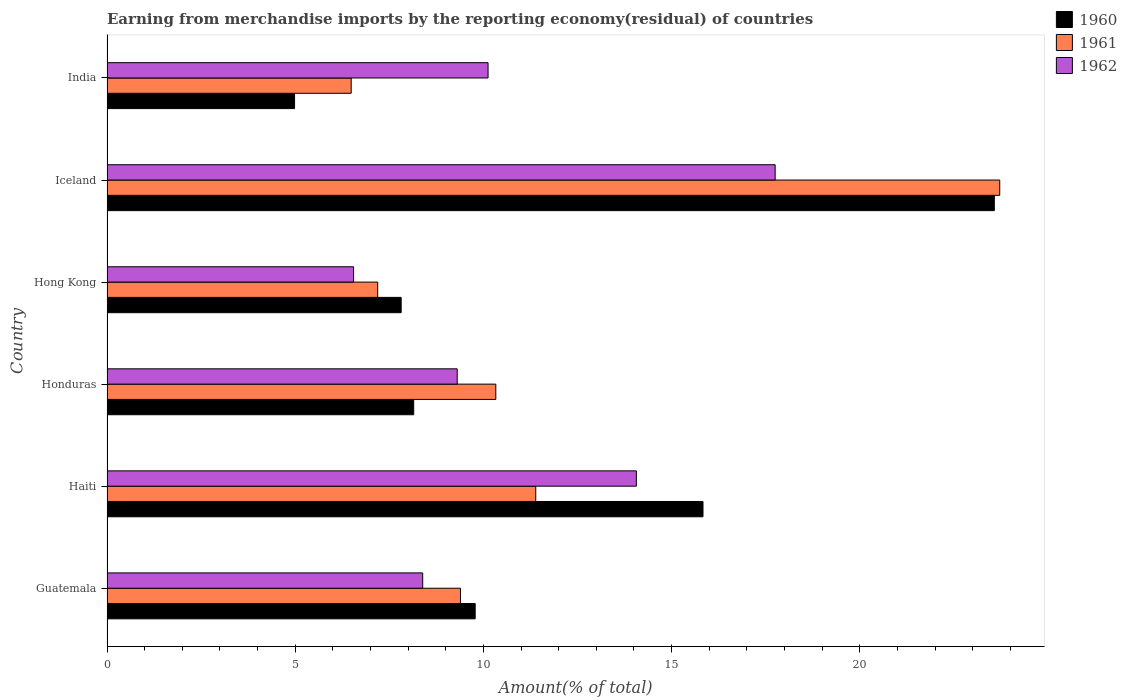How many different coloured bars are there?
Provide a short and direct response. 3. How many groups of bars are there?
Provide a succinct answer. 6. Are the number of bars on each tick of the Y-axis equal?
Your answer should be compact. Yes. In how many cases, is the number of bars for a given country not equal to the number of legend labels?
Your answer should be very brief. 0. What is the percentage of amount earned from merchandise imports in 1962 in Honduras?
Keep it short and to the point. 9.31. Across all countries, what is the maximum percentage of amount earned from merchandise imports in 1960?
Offer a terse response. 23.58. Across all countries, what is the minimum percentage of amount earned from merchandise imports in 1960?
Offer a terse response. 4.98. In which country was the percentage of amount earned from merchandise imports in 1960 minimum?
Your response must be concise. India. What is the total percentage of amount earned from merchandise imports in 1961 in the graph?
Your answer should be compact. 68.51. What is the difference between the percentage of amount earned from merchandise imports in 1962 in Guatemala and that in Iceland?
Give a very brief answer. -9.36. What is the difference between the percentage of amount earned from merchandise imports in 1961 in Guatemala and the percentage of amount earned from merchandise imports in 1962 in Hong Kong?
Make the answer very short. 2.84. What is the average percentage of amount earned from merchandise imports in 1962 per country?
Your answer should be very brief. 11.03. What is the difference between the percentage of amount earned from merchandise imports in 1960 and percentage of amount earned from merchandise imports in 1962 in Honduras?
Your answer should be very brief. -1.16. What is the ratio of the percentage of amount earned from merchandise imports in 1961 in Guatemala to that in Iceland?
Ensure brevity in your answer.  0.4. Is the difference between the percentage of amount earned from merchandise imports in 1960 in Guatemala and Hong Kong greater than the difference between the percentage of amount earned from merchandise imports in 1962 in Guatemala and Hong Kong?
Provide a succinct answer. Yes. What is the difference between the highest and the second highest percentage of amount earned from merchandise imports in 1962?
Give a very brief answer. 3.69. What is the difference between the highest and the lowest percentage of amount earned from merchandise imports in 1961?
Offer a very short reply. 17.23. Is the sum of the percentage of amount earned from merchandise imports in 1961 in Hong Kong and Iceland greater than the maximum percentage of amount earned from merchandise imports in 1960 across all countries?
Your answer should be very brief. Yes. Are the values on the major ticks of X-axis written in scientific E-notation?
Your answer should be compact. No. Does the graph contain grids?
Keep it short and to the point. No. Where does the legend appear in the graph?
Your answer should be very brief. Top right. How are the legend labels stacked?
Your answer should be compact. Vertical. What is the title of the graph?
Provide a succinct answer. Earning from merchandise imports by the reporting economy(residual) of countries. Does "1972" appear as one of the legend labels in the graph?
Keep it short and to the point. No. What is the label or title of the X-axis?
Offer a very short reply. Amount(% of total). What is the label or title of the Y-axis?
Provide a succinct answer. Country. What is the Amount(% of total) in 1960 in Guatemala?
Your response must be concise. 9.78. What is the Amount(% of total) in 1961 in Guatemala?
Your answer should be very brief. 9.39. What is the Amount(% of total) in 1962 in Guatemala?
Provide a succinct answer. 8.39. What is the Amount(% of total) of 1960 in Haiti?
Your response must be concise. 15.84. What is the Amount(% of total) in 1961 in Haiti?
Make the answer very short. 11.39. What is the Amount(% of total) in 1962 in Haiti?
Offer a very short reply. 14.06. What is the Amount(% of total) in 1960 in Honduras?
Make the answer very short. 8.15. What is the Amount(% of total) in 1961 in Honduras?
Keep it short and to the point. 10.33. What is the Amount(% of total) in 1962 in Honduras?
Ensure brevity in your answer.  9.31. What is the Amount(% of total) of 1960 in Hong Kong?
Your answer should be very brief. 7.82. What is the Amount(% of total) of 1961 in Hong Kong?
Your response must be concise. 7.19. What is the Amount(% of total) of 1962 in Hong Kong?
Your answer should be compact. 6.55. What is the Amount(% of total) in 1960 in Iceland?
Offer a terse response. 23.58. What is the Amount(% of total) in 1961 in Iceland?
Keep it short and to the point. 23.72. What is the Amount(% of total) of 1962 in Iceland?
Offer a very short reply. 17.75. What is the Amount(% of total) of 1960 in India?
Keep it short and to the point. 4.98. What is the Amount(% of total) in 1961 in India?
Offer a terse response. 6.49. What is the Amount(% of total) of 1962 in India?
Your answer should be very brief. 10.12. Across all countries, what is the maximum Amount(% of total) in 1960?
Your answer should be compact. 23.58. Across all countries, what is the maximum Amount(% of total) of 1961?
Your answer should be very brief. 23.72. Across all countries, what is the maximum Amount(% of total) of 1962?
Offer a very short reply. 17.75. Across all countries, what is the minimum Amount(% of total) in 1960?
Provide a succinct answer. 4.98. Across all countries, what is the minimum Amount(% of total) of 1961?
Offer a very short reply. 6.49. Across all countries, what is the minimum Amount(% of total) of 1962?
Provide a succinct answer. 6.55. What is the total Amount(% of total) in 1960 in the graph?
Make the answer very short. 70.14. What is the total Amount(% of total) of 1961 in the graph?
Keep it short and to the point. 68.51. What is the total Amount(% of total) of 1962 in the graph?
Give a very brief answer. 66.19. What is the difference between the Amount(% of total) in 1960 in Guatemala and that in Haiti?
Offer a very short reply. -6.05. What is the difference between the Amount(% of total) in 1961 in Guatemala and that in Haiti?
Ensure brevity in your answer.  -2. What is the difference between the Amount(% of total) of 1962 in Guatemala and that in Haiti?
Your answer should be compact. -5.68. What is the difference between the Amount(% of total) in 1960 in Guatemala and that in Honduras?
Provide a short and direct response. 1.63. What is the difference between the Amount(% of total) of 1961 in Guatemala and that in Honduras?
Offer a very short reply. -0.94. What is the difference between the Amount(% of total) of 1962 in Guatemala and that in Honduras?
Ensure brevity in your answer.  -0.92. What is the difference between the Amount(% of total) of 1960 in Guatemala and that in Hong Kong?
Make the answer very short. 1.97. What is the difference between the Amount(% of total) of 1961 in Guatemala and that in Hong Kong?
Give a very brief answer. 2.2. What is the difference between the Amount(% of total) of 1962 in Guatemala and that in Hong Kong?
Offer a very short reply. 1.84. What is the difference between the Amount(% of total) of 1960 in Guatemala and that in Iceland?
Provide a succinct answer. -13.79. What is the difference between the Amount(% of total) in 1961 in Guatemala and that in Iceland?
Provide a short and direct response. -14.33. What is the difference between the Amount(% of total) of 1962 in Guatemala and that in Iceland?
Your answer should be very brief. -9.36. What is the difference between the Amount(% of total) of 1960 in Guatemala and that in India?
Offer a very short reply. 4.8. What is the difference between the Amount(% of total) of 1961 in Guatemala and that in India?
Make the answer very short. 2.9. What is the difference between the Amount(% of total) of 1962 in Guatemala and that in India?
Provide a succinct answer. -1.74. What is the difference between the Amount(% of total) of 1960 in Haiti and that in Honduras?
Offer a very short reply. 7.69. What is the difference between the Amount(% of total) in 1961 in Haiti and that in Honduras?
Provide a succinct answer. 1.06. What is the difference between the Amount(% of total) of 1962 in Haiti and that in Honduras?
Offer a very short reply. 4.76. What is the difference between the Amount(% of total) of 1960 in Haiti and that in Hong Kong?
Offer a terse response. 8.02. What is the difference between the Amount(% of total) of 1961 in Haiti and that in Hong Kong?
Give a very brief answer. 4.2. What is the difference between the Amount(% of total) of 1962 in Haiti and that in Hong Kong?
Provide a succinct answer. 7.51. What is the difference between the Amount(% of total) of 1960 in Haiti and that in Iceland?
Offer a terse response. -7.74. What is the difference between the Amount(% of total) of 1961 in Haiti and that in Iceland?
Your response must be concise. -12.33. What is the difference between the Amount(% of total) in 1962 in Haiti and that in Iceland?
Offer a terse response. -3.69. What is the difference between the Amount(% of total) in 1960 in Haiti and that in India?
Provide a succinct answer. 10.85. What is the difference between the Amount(% of total) in 1961 in Haiti and that in India?
Your response must be concise. 4.9. What is the difference between the Amount(% of total) in 1962 in Haiti and that in India?
Provide a short and direct response. 3.94. What is the difference between the Amount(% of total) of 1961 in Honduras and that in Hong Kong?
Provide a succinct answer. 3.14. What is the difference between the Amount(% of total) of 1962 in Honduras and that in Hong Kong?
Your response must be concise. 2.75. What is the difference between the Amount(% of total) of 1960 in Honduras and that in Iceland?
Keep it short and to the point. -15.43. What is the difference between the Amount(% of total) of 1961 in Honduras and that in Iceland?
Provide a succinct answer. -13.39. What is the difference between the Amount(% of total) in 1962 in Honduras and that in Iceland?
Your response must be concise. -8.45. What is the difference between the Amount(% of total) in 1960 in Honduras and that in India?
Provide a short and direct response. 3.17. What is the difference between the Amount(% of total) in 1961 in Honduras and that in India?
Your response must be concise. 3.84. What is the difference between the Amount(% of total) of 1962 in Honduras and that in India?
Make the answer very short. -0.82. What is the difference between the Amount(% of total) of 1960 in Hong Kong and that in Iceland?
Provide a short and direct response. -15.76. What is the difference between the Amount(% of total) in 1961 in Hong Kong and that in Iceland?
Provide a succinct answer. -16.53. What is the difference between the Amount(% of total) of 1962 in Hong Kong and that in Iceland?
Ensure brevity in your answer.  -11.2. What is the difference between the Amount(% of total) of 1960 in Hong Kong and that in India?
Give a very brief answer. 2.83. What is the difference between the Amount(% of total) in 1961 in Hong Kong and that in India?
Give a very brief answer. 0.7. What is the difference between the Amount(% of total) of 1962 in Hong Kong and that in India?
Your answer should be very brief. -3.57. What is the difference between the Amount(% of total) of 1960 in Iceland and that in India?
Keep it short and to the point. 18.59. What is the difference between the Amount(% of total) in 1961 in Iceland and that in India?
Provide a succinct answer. 17.23. What is the difference between the Amount(% of total) in 1962 in Iceland and that in India?
Offer a terse response. 7.63. What is the difference between the Amount(% of total) in 1960 in Guatemala and the Amount(% of total) in 1961 in Haiti?
Offer a terse response. -1.61. What is the difference between the Amount(% of total) in 1960 in Guatemala and the Amount(% of total) in 1962 in Haiti?
Make the answer very short. -4.28. What is the difference between the Amount(% of total) of 1961 in Guatemala and the Amount(% of total) of 1962 in Haiti?
Provide a succinct answer. -4.67. What is the difference between the Amount(% of total) of 1960 in Guatemala and the Amount(% of total) of 1961 in Honduras?
Provide a succinct answer. -0.55. What is the difference between the Amount(% of total) in 1960 in Guatemala and the Amount(% of total) in 1962 in Honduras?
Your answer should be compact. 0.48. What is the difference between the Amount(% of total) of 1961 in Guatemala and the Amount(% of total) of 1962 in Honduras?
Your response must be concise. 0.09. What is the difference between the Amount(% of total) in 1960 in Guatemala and the Amount(% of total) in 1961 in Hong Kong?
Ensure brevity in your answer.  2.59. What is the difference between the Amount(% of total) in 1960 in Guatemala and the Amount(% of total) in 1962 in Hong Kong?
Make the answer very short. 3.23. What is the difference between the Amount(% of total) in 1961 in Guatemala and the Amount(% of total) in 1962 in Hong Kong?
Keep it short and to the point. 2.84. What is the difference between the Amount(% of total) of 1960 in Guatemala and the Amount(% of total) of 1961 in Iceland?
Provide a short and direct response. -13.94. What is the difference between the Amount(% of total) of 1960 in Guatemala and the Amount(% of total) of 1962 in Iceland?
Offer a terse response. -7.97. What is the difference between the Amount(% of total) in 1961 in Guatemala and the Amount(% of total) in 1962 in Iceland?
Keep it short and to the point. -8.36. What is the difference between the Amount(% of total) of 1960 in Guatemala and the Amount(% of total) of 1961 in India?
Your answer should be compact. 3.29. What is the difference between the Amount(% of total) in 1960 in Guatemala and the Amount(% of total) in 1962 in India?
Provide a short and direct response. -0.34. What is the difference between the Amount(% of total) in 1961 in Guatemala and the Amount(% of total) in 1962 in India?
Provide a succinct answer. -0.73. What is the difference between the Amount(% of total) in 1960 in Haiti and the Amount(% of total) in 1961 in Honduras?
Provide a short and direct response. 5.51. What is the difference between the Amount(% of total) in 1960 in Haiti and the Amount(% of total) in 1962 in Honduras?
Your response must be concise. 6.53. What is the difference between the Amount(% of total) in 1961 in Haiti and the Amount(% of total) in 1962 in Honduras?
Offer a very short reply. 2.09. What is the difference between the Amount(% of total) in 1960 in Haiti and the Amount(% of total) in 1961 in Hong Kong?
Keep it short and to the point. 8.64. What is the difference between the Amount(% of total) in 1960 in Haiti and the Amount(% of total) in 1962 in Hong Kong?
Ensure brevity in your answer.  9.28. What is the difference between the Amount(% of total) of 1961 in Haiti and the Amount(% of total) of 1962 in Hong Kong?
Provide a succinct answer. 4.84. What is the difference between the Amount(% of total) in 1960 in Haiti and the Amount(% of total) in 1961 in Iceland?
Your response must be concise. -7.88. What is the difference between the Amount(% of total) in 1960 in Haiti and the Amount(% of total) in 1962 in Iceland?
Make the answer very short. -1.92. What is the difference between the Amount(% of total) in 1961 in Haiti and the Amount(% of total) in 1962 in Iceland?
Your answer should be very brief. -6.36. What is the difference between the Amount(% of total) of 1960 in Haiti and the Amount(% of total) of 1961 in India?
Offer a very short reply. 9.35. What is the difference between the Amount(% of total) in 1960 in Haiti and the Amount(% of total) in 1962 in India?
Your response must be concise. 5.71. What is the difference between the Amount(% of total) of 1961 in Haiti and the Amount(% of total) of 1962 in India?
Offer a terse response. 1.27. What is the difference between the Amount(% of total) in 1960 in Honduras and the Amount(% of total) in 1961 in Hong Kong?
Ensure brevity in your answer.  0.96. What is the difference between the Amount(% of total) in 1960 in Honduras and the Amount(% of total) in 1962 in Hong Kong?
Your response must be concise. 1.6. What is the difference between the Amount(% of total) of 1961 in Honduras and the Amount(% of total) of 1962 in Hong Kong?
Provide a succinct answer. 3.78. What is the difference between the Amount(% of total) in 1960 in Honduras and the Amount(% of total) in 1961 in Iceland?
Ensure brevity in your answer.  -15.57. What is the difference between the Amount(% of total) in 1960 in Honduras and the Amount(% of total) in 1962 in Iceland?
Offer a very short reply. -9.6. What is the difference between the Amount(% of total) in 1961 in Honduras and the Amount(% of total) in 1962 in Iceland?
Offer a very short reply. -7.42. What is the difference between the Amount(% of total) in 1960 in Honduras and the Amount(% of total) in 1961 in India?
Keep it short and to the point. 1.66. What is the difference between the Amount(% of total) in 1960 in Honduras and the Amount(% of total) in 1962 in India?
Your answer should be very brief. -1.98. What is the difference between the Amount(% of total) of 1961 in Honduras and the Amount(% of total) of 1962 in India?
Give a very brief answer. 0.21. What is the difference between the Amount(% of total) in 1960 in Hong Kong and the Amount(% of total) in 1961 in Iceland?
Your response must be concise. -15.9. What is the difference between the Amount(% of total) in 1960 in Hong Kong and the Amount(% of total) in 1962 in Iceland?
Offer a very short reply. -9.94. What is the difference between the Amount(% of total) of 1961 in Hong Kong and the Amount(% of total) of 1962 in Iceland?
Your answer should be very brief. -10.56. What is the difference between the Amount(% of total) in 1960 in Hong Kong and the Amount(% of total) in 1961 in India?
Make the answer very short. 1.33. What is the difference between the Amount(% of total) of 1960 in Hong Kong and the Amount(% of total) of 1962 in India?
Provide a short and direct response. -2.31. What is the difference between the Amount(% of total) of 1961 in Hong Kong and the Amount(% of total) of 1962 in India?
Provide a short and direct response. -2.93. What is the difference between the Amount(% of total) of 1960 in Iceland and the Amount(% of total) of 1961 in India?
Offer a terse response. 17.09. What is the difference between the Amount(% of total) in 1960 in Iceland and the Amount(% of total) in 1962 in India?
Your answer should be compact. 13.45. What is the difference between the Amount(% of total) in 1961 in Iceland and the Amount(% of total) in 1962 in India?
Offer a terse response. 13.6. What is the average Amount(% of total) in 1960 per country?
Give a very brief answer. 11.69. What is the average Amount(% of total) of 1961 per country?
Your answer should be compact. 11.42. What is the average Amount(% of total) of 1962 per country?
Your answer should be very brief. 11.03. What is the difference between the Amount(% of total) of 1960 and Amount(% of total) of 1961 in Guatemala?
Give a very brief answer. 0.39. What is the difference between the Amount(% of total) in 1960 and Amount(% of total) in 1962 in Guatemala?
Provide a succinct answer. 1.39. What is the difference between the Amount(% of total) in 1961 and Amount(% of total) in 1962 in Guatemala?
Provide a short and direct response. 1. What is the difference between the Amount(% of total) of 1960 and Amount(% of total) of 1961 in Haiti?
Your answer should be very brief. 4.44. What is the difference between the Amount(% of total) in 1960 and Amount(% of total) in 1962 in Haiti?
Provide a succinct answer. 1.77. What is the difference between the Amount(% of total) of 1961 and Amount(% of total) of 1962 in Haiti?
Your response must be concise. -2.67. What is the difference between the Amount(% of total) of 1960 and Amount(% of total) of 1961 in Honduras?
Make the answer very short. -2.18. What is the difference between the Amount(% of total) in 1960 and Amount(% of total) in 1962 in Honduras?
Provide a succinct answer. -1.16. What is the difference between the Amount(% of total) in 1961 and Amount(% of total) in 1962 in Honduras?
Make the answer very short. 1.03. What is the difference between the Amount(% of total) in 1960 and Amount(% of total) in 1961 in Hong Kong?
Provide a succinct answer. 0.62. What is the difference between the Amount(% of total) of 1960 and Amount(% of total) of 1962 in Hong Kong?
Ensure brevity in your answer.  1.26. What is the difference between the Amount(% of total) in 1961 and Amount(% of total) in 1962 in Hong Kong?
Offer a very short reply. 0.64. What is the difference between the Amount(% of total) of 1960 and Amount(% of total) of 1961 in Iceland?
Keep it short and to the point. -0.14. What is the difference between the Amount(% of total) in 1960 and Amount(% of total) in 1962 in Iceland?
Ensure brevity in your answer.  5.82. What is the difference between the Amount(% of total) in 1961 and Amount(% of total) in 1962 in Iceland?
Provide a succinct answer. 5.97. What is the difference between the Amount(% of total) of 1960 and Amount(% of total) of 1961 in India?
Your answer should be compact. -1.5. What is the difference between the Amount(% of total) in 1960 and Amount(% of total) in 1962 in India?
Give a very brief answer. -5.14. What is the difference between the Amount(% of total) of 1961 and Amount(% of total) of 1962 in India?
Provide a succinct answer. -3.64. What is the ratio of the Amount(% of total) in 1960 in Guatemala to that in Haiti?
Provide a short and direct response. 0.62. What is the ratio of the Amount(% of total) of 1961 in Guatemala to that in Haiti?
Your answer should be very brief. 0.82. What is the ratio of the Amount(% of total) of 1962 in Guatemala to that in Haiti?
Offer a terse response. 0.6. What is the ratio of the Amount(% of total) of 1960 in Guatemala to that in Honduras?
Your answer should be compact. 1.2. What is the ratio of the Amount(% of total) in 1962 in Guatemala to that in Honduras?
Keep it short and to the point. 0.9. What is the ratio of the Amount(% of total) of 1960 in Guatemala to that in Hong Kong?
Your response must be concise. 1.25. What is the ratio of the Amount(% of total) in 1961 in Guatemala to that in Hong Kong?
Offer a terse response. 1.31. What is the ratio of the Amount(% of total) of 1962 in Guatemala to that in Hong Kong?
Provide a short and direct response. 1.28. What is the ratio of the Amount(% of total) of 1960 in Guatemala to that in Iceland?
Your answer should be compact. 0.41. What is the ratio of the Amount(% of total) of 1961 in Guatemala to that in Iceland?
Your answer should be very brief. 0.4. What is the ratio of the Amount(% of total) of 1962 in Guatemala to that in Iceland?
Keep it short and to the point. 0.47. What is the ratio of the Amount(% of total) in 1960 in Guatemala to that in India?
Your response must be concise. 1.96. What is the ratio of the Amount(% of total) of 1961 in Guatemala to that in India?
Your answer should be very brief. 1.45. What is the ratio of the Amount(% of total) of 1962 in Guatemala to that in India?
Keep it short and to the point. 0.83. What is the ratio of the Amount(% of total) of 1960 in Haiti to that in Honduras?
Provide a short and direct response. 1.94. What is the ratio of the Amount(% of total) of 1961 in Haiti to that in Honduras?
Ensure brevity in your answer.  1.1. What is the ratio of the Amount(% of total) of 1962 in Haiti to that in Honduras?
Keep it short and to the point. 1.51. What is the ratio of the Amount(% of total) in 1960 in Haiti to that in Hong Kong?
Provide a short and direct response. 2.03. What is the ratio of the Amount(% of total) of 1961 in Haiti to that in Hong Kong?
Give a very brief answer. 1.58. What is the ratio of the Amount(% of total) in 1962 in Haiti to that in Hong Kong?
Offer a very short reply. 2.15. What is the ratio of the Amount(% of total) in 1960 in Haiti to that in Iceland?
Give a very brief answer. 0.67. What is the ratio of the Amount(% of total) of 1961 in Haiti to that in Iceland?
Offer a terse response. 0.48. What is the ratio of the Amount(% of total) in 1962 in Haiti to that in Iceland?
Provide a succinct answer. 0.79. What is the ratio of the Amount(% of total) of 1960 in Haiti to that in India?
Provide a succinct answer. 3.18. What is the ratio of the Amount(% of total) of 1961 in Haiti to that in India?
Provide a short and direct response. 1.76. What is the ratio of the Amount(% of total) of 1962 in Haiti to that in India?
Ensure brevity in your answer.  1.39. What is the ratio of the Amount(% of total) of 1960 in Honduras to that in Hong Kong?
Provide a succinct answer. 1.04. What is the ratio of the Amount(% of total) in 1961 in Honduras to that in Hong Kong?
Ensure brevity in your answer.  1.44. What is the ratio of the Amount(% of total) of 1962 in Honduras to that in Hong Kong?
Give a very brief answer. 1.42. What is the ratio of the Amount(% of total) in 1960 in Honduras to that in Iceland?
Offer a terse response. 0.35. What is the ratio of the Amount(% of total) in 1961 in Honduras to that in Iceland?
Keep it short and to the point. 0.44. What is the ratio of the Amount(% of total) of 1962 in Honduras to that in Iceland?
Provide a succinct answer. 0.52. What is the ratio of the Amount(% of total) in 1960 in Honduras to that in India?
Your answer should be compact. 1.64. What is the ratio of the Amount(% of total) in 1961 in Honduras to that in India?
Your answer should be compact. 1.59. What is the ratio of the Amount(% of total) of 1962 in Honduras to that in India?
Ensure brevity in your answer.  0.92. What is the ratio of the Amount(% of total) in 1960 in Hong Kong to that in Iceland?
Offer a terse response. 0.33. What is the ratio of the Amount(% of total) in 1961 in Hong Kong to that in Iceland?
Your answer should be compact. 0.3. What is the ratio of the Amount(% of total) of 1962 in Hong Kong to that in Iceland?
Provide a succinct answer. 0.37. What is the ratio of the Amount(% of total) in 1960 in Hong Kong to that in India?
Your answer should be compact. 1.57. What is the ratio of the Amount(% of total) in 1961 in Hong Kong to that in India?
Give a very brief answer. 1.11. What is the ratio of the Amount(% of total) of 1962 in Hong Kong to that in India?
Provide a short and direct response. 0.65. What is the ratio of the Amount(% of total) in 1960 in Iceland to that in India?
Ensure brevity in your answer.  4.73. What is the ratio of the Amount(% of total) of 1961 in Iceland to that in India?
Provide a succinct answer. 3.66. What is the ratio of the Amount(% of total) in 1962 in Iceland to that in India?
Provide a short and direct response. 1.75. What is the difference between the highest and the second highest Amount(% of total) in 1960?
Give a very brief answer. 7.74. What is the difference between the highest and the second highest Amount(% of total) in 1961?
Provide a succinct answer. 12.33. What is the difference between the highest and the second highest Amount(% of total) of 1962?
Your response must be concise. 3.69. What is the difference between the highest and the lowest Amount(% of total) of 1960?
Your answer should be very brief. 18.59. What is the difference between the highest and the lowest Amount(% of total) of 1961?
Offer a very short reply. 17.23. What is the difference between the highest and the lowest Amount(% of total) in 1962?
Keep it short and to the point. 11.2. 